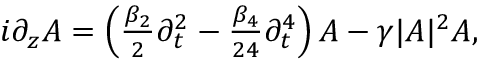Convert formula to latex. <formula><loc_0><loc_0><loc_500><loc_500>\begin{array} { r } { i \partial _ { z } A = \left ( \frac { \beta _ { 2 } } { 2 } \partial _ { t } ^ { 2 } - \frac { \beta _ { 4 } } { 2 4 } \partial _ { t } ^ { 4 } \right ) A - \gamma | A | ^ { 2 } A , } \end{array}</formula> 